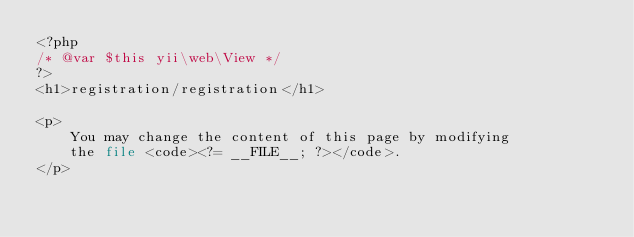<code> <loc_0><loc_0><loc_500><loc_500><_PHP_><?php
/* @var $this yii\web\View */
?>
<h1>registration/registration</h1>

<p>
    You may change the content of this page by modifying
    the file <code><?= __FILE__; ?></code>.
</p>
</code> 